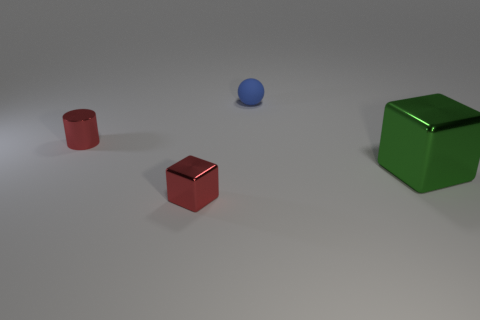Add 2 cubes. How many objects exist? 6 Subtract all cylinders. How many objects are left? 3 Subtract all cylinders. Subtract all small red metal cylinders. How many objects are left? 2 Add 2 large metallic cubes. How many large metallic cubes are left? 3 Add 4 small yellow metal balls. How many small yellow metal balls exist? 4 Subtract 0 cyan balls. How many objects are left? 4 